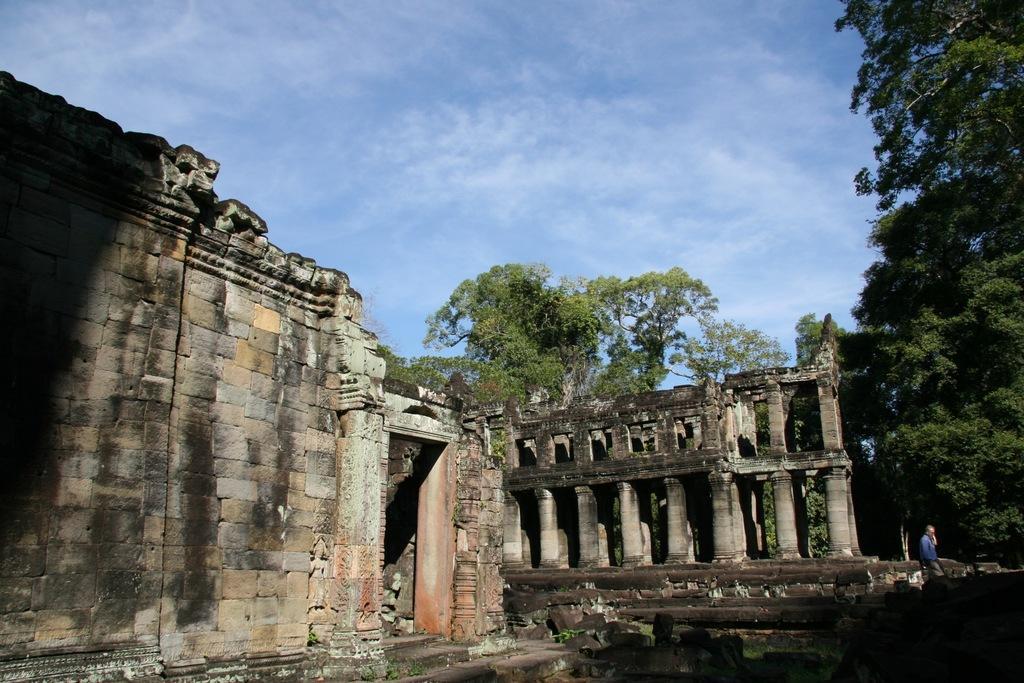Describe this image in one or two sentences. In this image we can see some old buildings, there are few trees and also few leaves, also there is a person walking through the buildings and some clouds in the sky. 